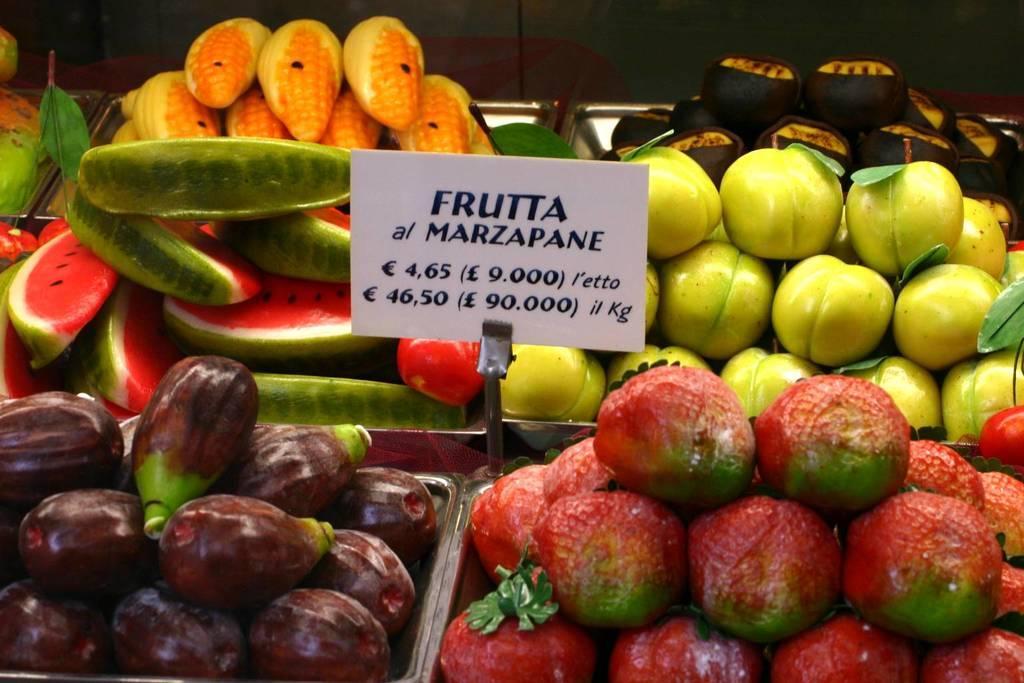Please provide a concise description of this image. Here in this picture we can see fruits and vegetables present in baskets over there and we can also see a rate card present in the middle over there. 